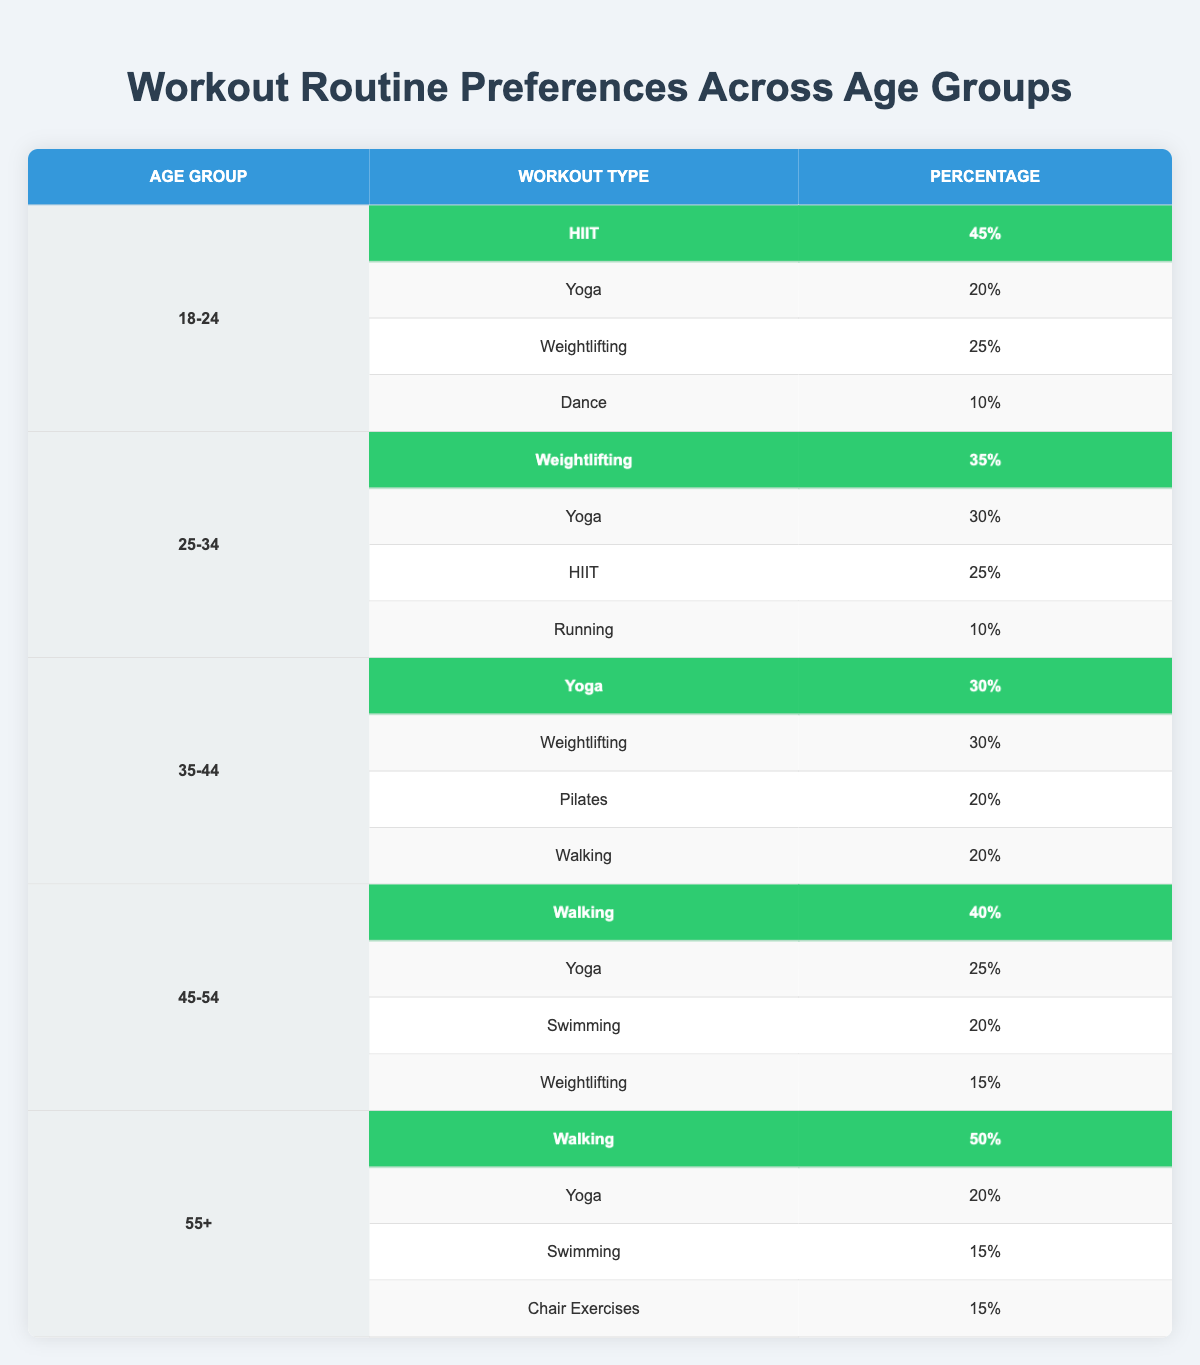What is the most preferred workout type among the 18-24 age group? The preferred workout type can be found in the row for the 18-24 age group. The workout type with the highest percentage is HIIT at 45%.
Answer: HIIT Which workout type is preferred by both the 25-34 and 35-44 age groups? Looking at both age groups, Weightlifting is mentioned in the 25-34 age group at 35% and in the 35-44 age group with a percentage of 30%.
Answer: Weightlifting What percentage of the 45-54 age group prefers Walking? The preferred workout type for Walking in the 45-54 age group is highlighted at 40%.
Answer: 40% Is Yoga more preferred by the 35-44 age group than by the 25-34 age group? Yoga is preferred at 30% in the 35-44 age group and 30% in the 25-34 age group, indicating they are equal, not one is more preferred over the other.
Answer: No What is the overall percentage of Yoga preference across all age groups? To find the overall percentage, sum the percentages of Yoga for each age group: 20% (18-24) + 30% (25-34) + 30% (35-44) + 25% (45-54) + 20% (55+) = 125%.
Answer: 125% Which age group has the highest overall percentage for Walking preference? The 55+ age group has the highest percentage preference for Walking at 50%, compared to 40% in the 45-54 age group and lower percentages in others.
Answer: 55+ How does the HIIT preference in the 18-24 age group compare to the Weightlifting preference in the 25-34 age group? The HIIT preference is at 45% for the 18-24 age group, while Weightlifting is at 35% for the 25-34 age group. HIIT is preferred more than Weightlifting between these two age groups.
Answer: HIIT is preferred more Are there any workout types that are preferred more than 40% by the age groups above 45? Only Walking is preferred more than 40%, specifically 50% in the 55+ age group and 40% in the 45-54 age group.
Answer: Yes What is the difference between the preferred percentages of Walking in the 45-54 and 55+ age groups? Walking is preferred at 40% in the 45-54 age group and 50% in the 55+ age group. The difference is 50% - 40% = 10%.
Answer: 10% What age group has the least preference for Dance? Dance has only 10% preference in the 18-24 age group, which is the least preference compared to other age groups listed.
Answer: 18-24 